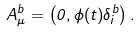<formula> <loc_0><loc_0><loc_500><loc_500>A _ { \mu } ^ { b } = \left ( 0 , \phi ( t ) \delta ^ { b } _ { i } \right ) .</formula> 